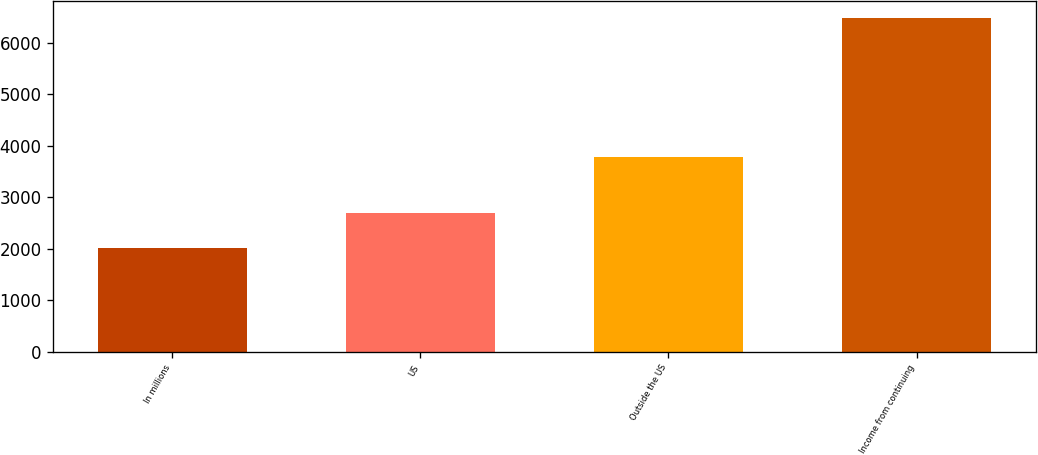Convert chart. <chart><loc_0><loc_0><loc_500><loc_500><bar_chart><fcel>In millions<fcel>US<fcel>Outside the US<fcel>Income from continuing<nl><fcel>2009<fcel>2700.4<fcel>3786.6<fcel>6487<nl></chart> 